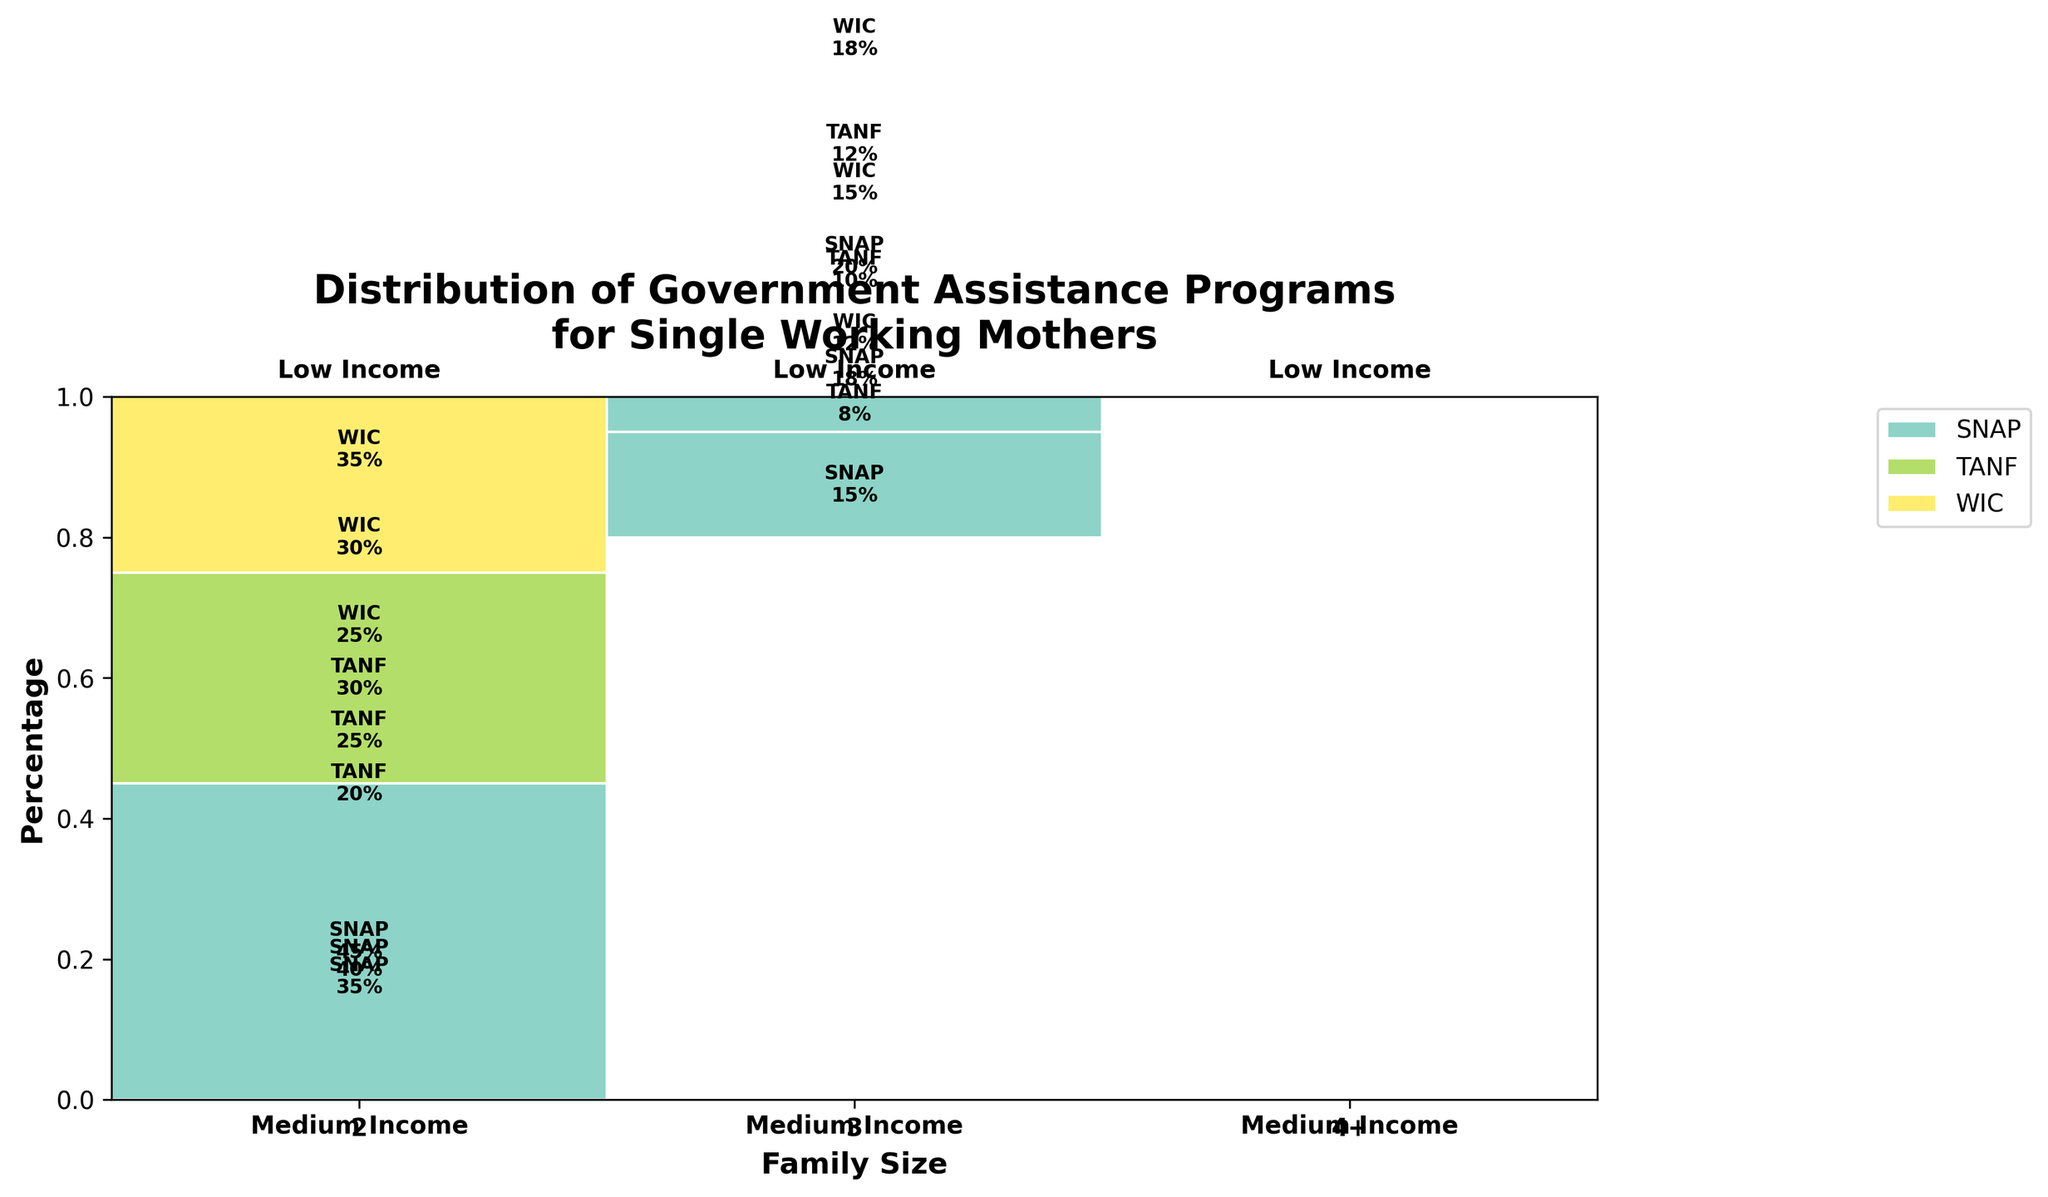What is the title of the figure? The title of the figure is displayed at the top in a bold font. By looking at the top of the figure, you can read the complete title.
Answer: Distribution of Government Assistance Programs for Single Working Mothers Which government assistance program has the highest percentage for families of size 3 with low income? Look at the segment for family size 3 and low income. Identify the program with the largest rectangle and highest percentage label within that area.
Answer: SNAP How does the percentage of families of size 4+ with medium income utilizing WIC compare to those utilizing TANF? Check the section for family size 4+ with medium income. Compare the height of the rectangles for WIC and TANF in that section.
Answer: WIC is higher What is the combined percentage for the TANF program among families with low income of any size? Find the TANF percentages in the low-income sections for all family sizes, then add them together: 20% for size 2, 25% for size 3, and 30% for size 4+.
Answer: 75% Which family size and income level has the smallest percentage for the WIC program? Identify the rectangles representing WIC in each section and compare their heights. The smallest rectangle indicates the smallest percentage.
Answer: Family size 2 with medium income What is the primary government assistance program for families of size 2 with low income? Locate the section for family size 2 with low income and identify the largest rectangle, which signifies the primary program.
Answer: SNAP Compare the usage of the SNAP program between families with low income and medium income for family size 4+. Look at the SNAP rectangles in both low-income and medium-income sections for family size 4+. Compare their heights and percentages.
Answer: Low income is higher What is the percentage difference in TANF utilization between families of size 3 with low income and medium income? Subtract the percentage of TANF utilization for medium income (10%) from the low income (25%).
Answer: 15% Which assistance program shows the least percentage utilization across all family sizes and income levels? Look at all the rectangles for each assistance program across all sections. Identify the smallest overall.
Answer: TANF 